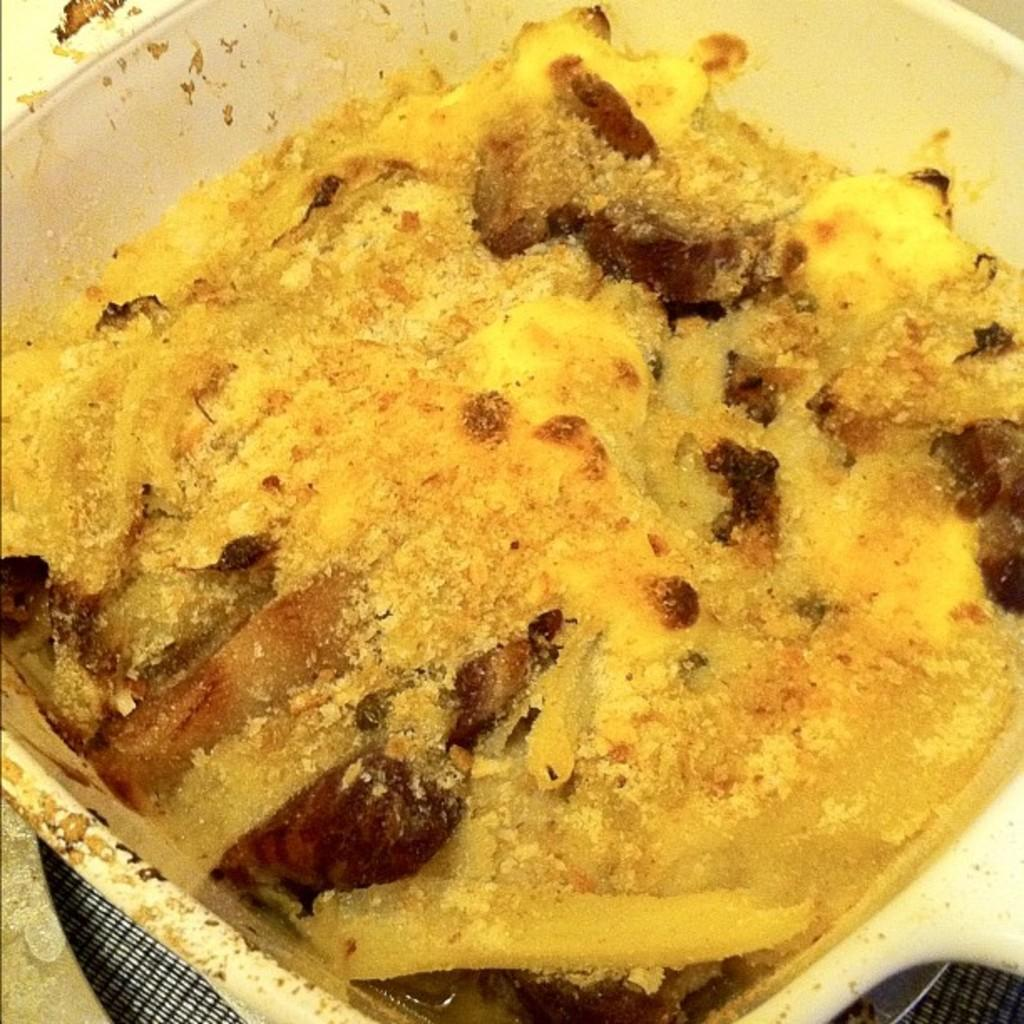What is in the bowl in the image? There is a food item in the bowl. 